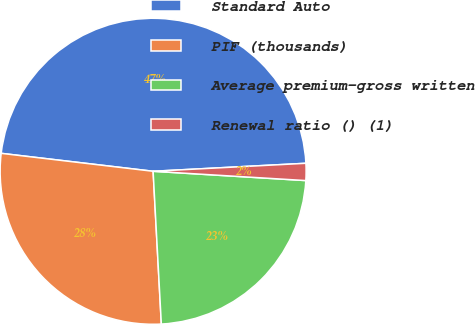Convert chart. <chart><loc_0><loc_0><loc_500><loc_500><pie_chart><fcel>Standard Auto<fcel>PIF (thousands)<fcel>Average premium-gross written<fcel>Renewal ratio () (1)<nl><fcel>47.3%<fcel>27.73%<fcel>23.18%<fcel>1.8%<nl></chart> 